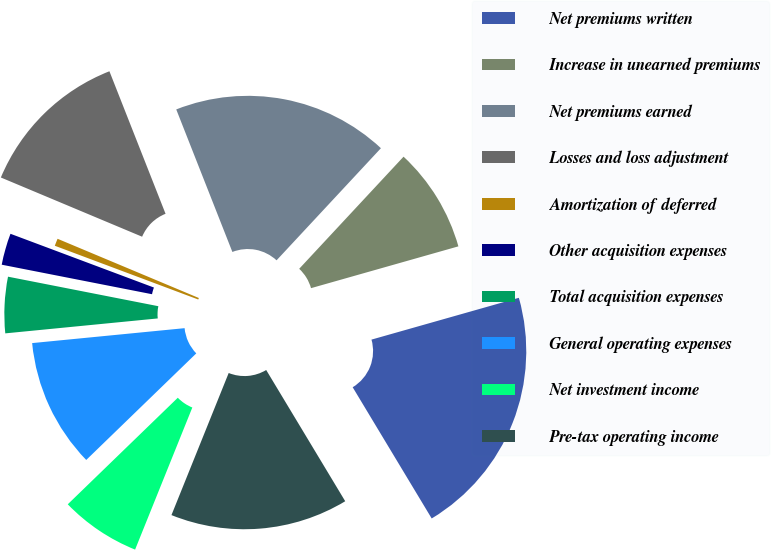<chart> <loc_0><loc_0><loc_500><loc_500><pie_chart><fcel>Net premiums written<fcel>Increase in unearned premiums<fcel>Net premiums earned<fcel>Losses and loss adjustment<fcel>Amortization of deferred<fcel>Other acquisition expenses<fcel>Total acquisition expenses<fcel>General operating expenses<fcel>Net investment income<fcel>Pre-tax operating income<nl><fcel>20.77%<fcel>8.67%<fcel>17.9%<fcel>12.71%<fcel>0.61%<fcel>2.62%<fcel>4.64%<fcel>10.69%<fcel>6.66%<fcel>14.72%<nl></chart> 